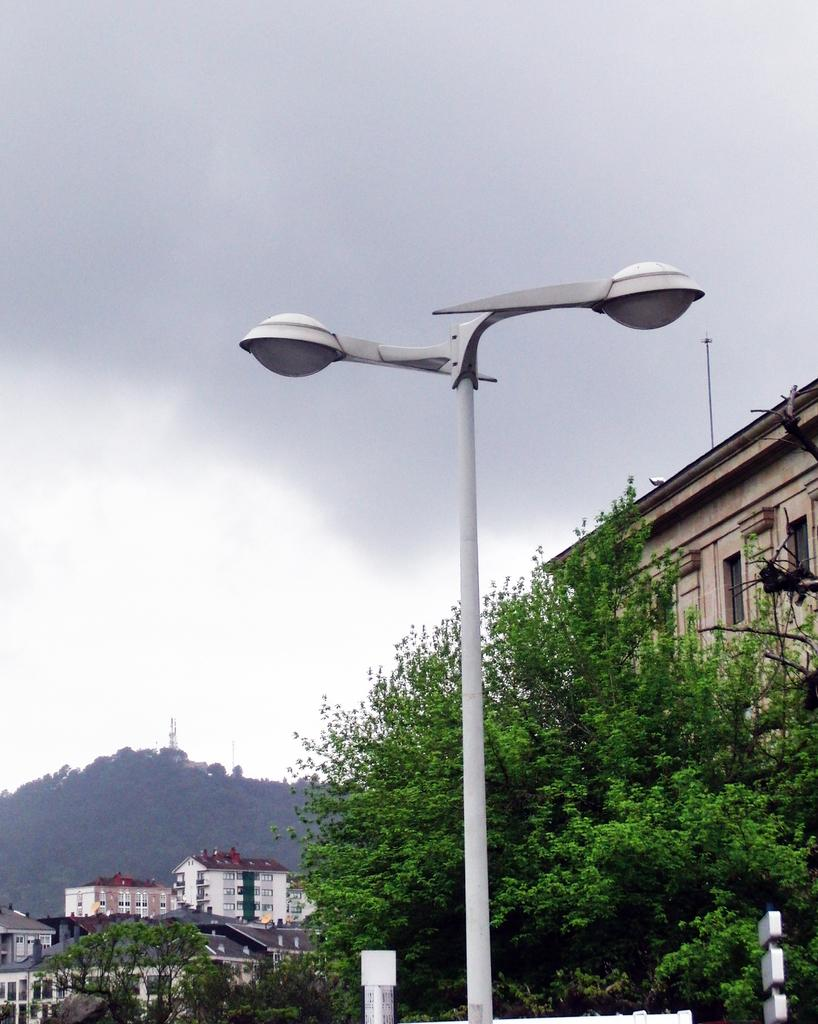What type of structures can be seen in the image? There are buildings in the image. What other natural elements are present in the image? There are trees in the image. What type of man-made object is visible in the image? There is a street light visible in the image. What part of the natural environment is visible in the image? The sky is visible in the image. What type of tooth is visible in the image? There is no tooth present in the image. How does the shop in the image connect to the buildings? There is no shop present in the image, so it cannot be connected to the buildings. 